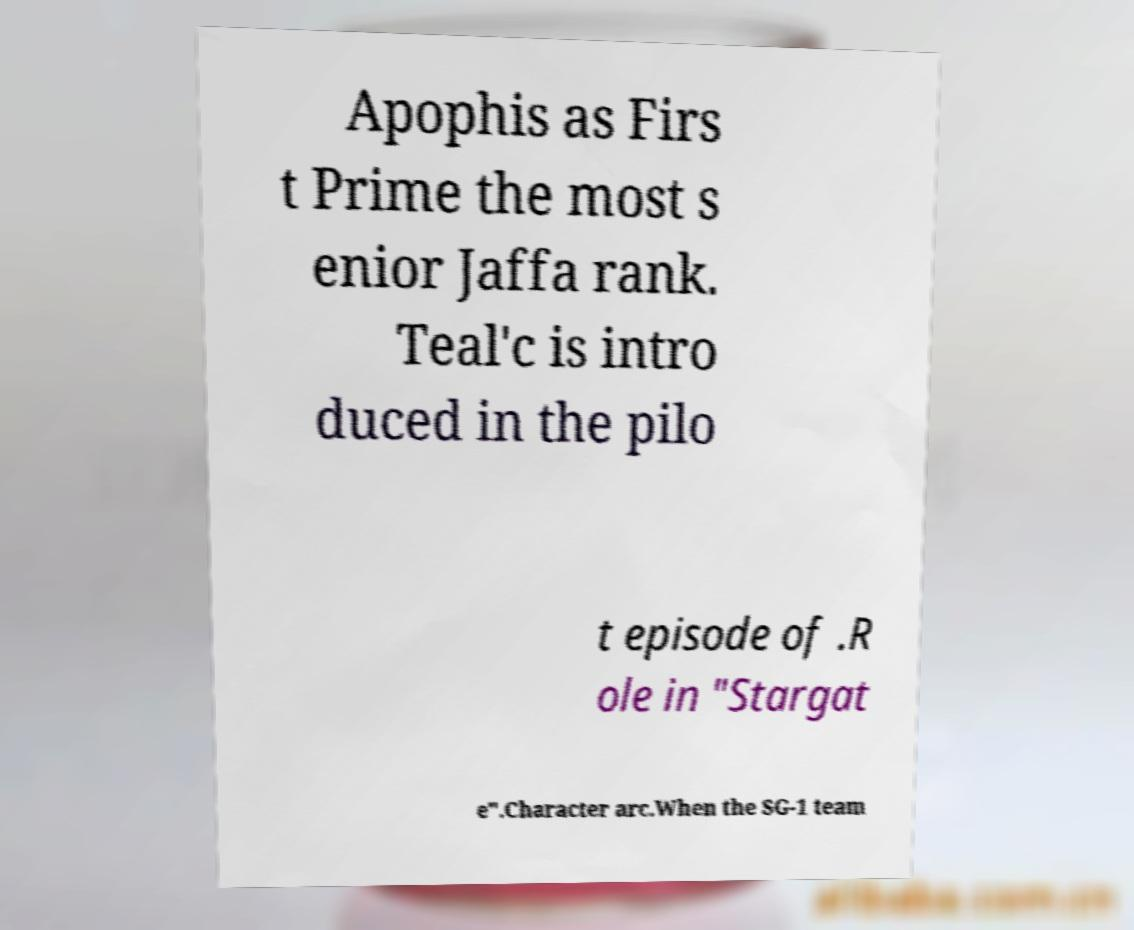Please identify and transcribe the text found in this image. Apophis as Firs t Prime the most s enior Jaffa rank. Teal'c is intro duced in the pilo t episode of .R ole in "Stargat e".Character arc.When the SG-1 team 